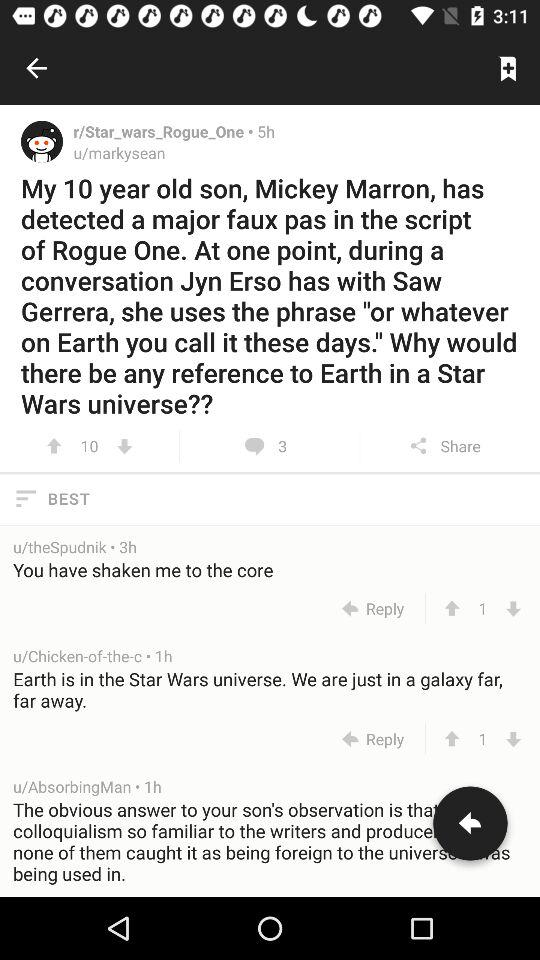Which comment has 92 likes?
When the provided information is insufficient, respond with <no answer>. <no answer> 